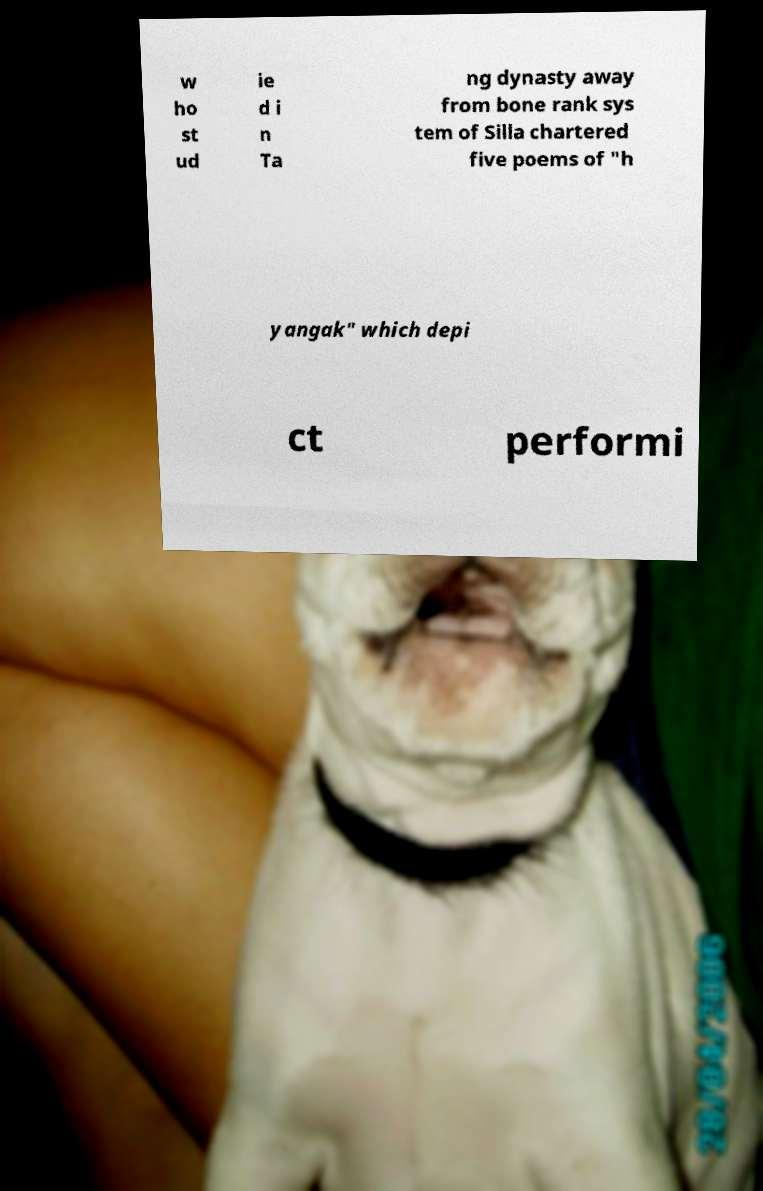Can you accurately transcribe the text from the provided image for me? w ho st ud ie d i n Ta ng dynasty away from bone rank sys tem of Silla chartered five poems of "h yangak" which depi ct performi 